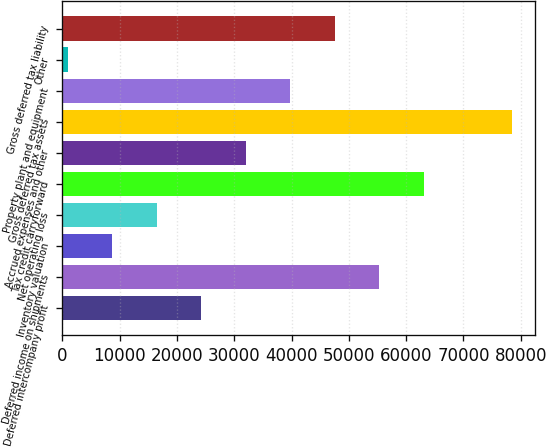Convert chart. <chart><loc_0><loc_0><loc_500><loc_500><bar_chart><fcel>Deferred intercompany profit<fcel>Deferred income on shipments<fcel>Inventory valuation<fcel>Net operating loss<fcel>Tax credit carryforward<fcel>Accrued expenses and other<fcel>Gross deferred tax assets<fcel>Property plant and equipment<fcel>Other<fcel>Gross deferred tax liability<nl><fcel>24250.6<fcel>55275.4<fcel>8738.2<fcel>16494.4<fcel>63031.6<fcel>32006.8<fcel>78544<fcel>39763<fcel>982<fcel>47519.2<nl></chart> 